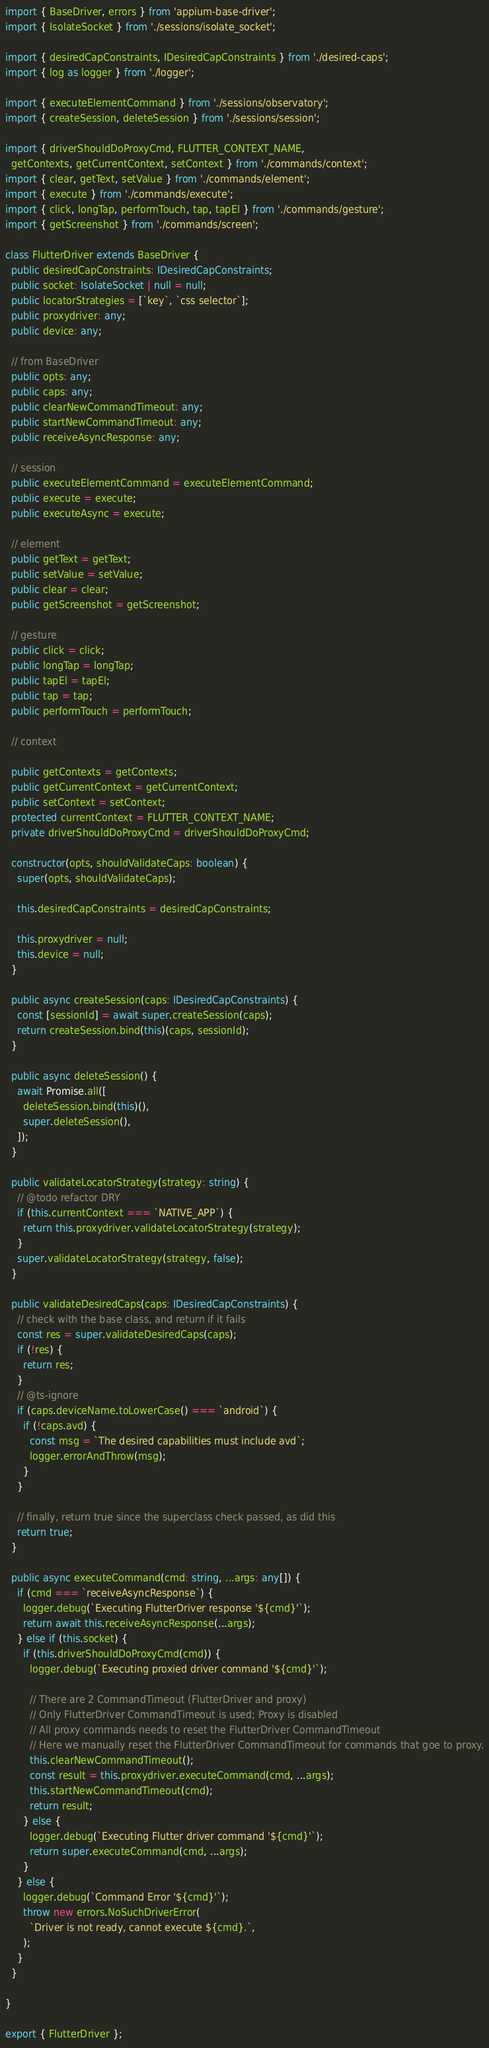<code> <loc_0><loc_0><loc_500><loc_500><_TypeScript_>import { BaseDriver, errors } from 'appium-base-driver';
import { IsolateSocket } from './sessions/isolate_socket';

import { desiredCapConstraints, IDesiredCapConstraints } from './desired-caps';
import { log as logger } from './logger';

import { executeElementCommand } from './sessions/observatory';
import { createSession, deleteSession } from './sessions/session';

import { driverShouldDoProxyCmd, FLUTTER_CONTEXT_NAME,
  getContexts, getCurrentContext, setContext } from './commands/context';
import { clear, getText, setValue } from './commands/element';
import { execute } from './commands/execute';
import { click, longTap, performTouch, tap, tapEl } from './commands/gesture';
import { getScreenshot } from './commands/screen';

class FlutterDriver extends BaseDriver {
  public desiredCapConstraints: IDesiredCapConstraints;
  public socket: IsolateSocket | null = null;
  public locatorStrategies = [`key`, `css selector`];
  public proxydriver: any;
  public device: any;

  // from BaseDriver
  public opts: any;
  public caps: any;
  public clearNewCommandTimeout: any;
  public startNewCommandTimeout: any;
  public receiveAsyncResponse: any;

  // session
  public executeElementCommand = executeElementCommand;
  public execute = execute;
  public executeAsync = execute;

  // element
  public getText = getText;
  public setValue = setValue;
  public clear = clear;
  public getScreenshot = getScreenshot;

  // gesture
  public click = click;
  public longTap = longTap;
  public tapEl = tapEl;
  public tap = tap;
  public performTouch = performTouch;

  // context

  public getContexts = getContexts;
  public getCurrentContext = getCurrentContext;
  public setContext = setContext;
  protected currentContext = FLUTTER_CONTEXT_NAME;
  private driverShouldDoProxyCmd = driverShouldDoProxyCmd;

  constructor(opts, shouldValidateCaps: boolean) {
    super(opts, shouldValidateCaps);

    this.desiredCapConstraints = desiredCapConstraints;

    this.proxydriver = null;
    this.device = null;
  }

  public async createSession(caps: IDesiredCapConstraints) {
    const [sessionId] = await super.createSession(caps);
    return createSession.bind(this)(caps, sessionId);
  }

  public async deleteSession() {
    await Promise.all([
      deleteSession.bind(this)(),
      super.deleteSession(),
    ]);
  }

  public validateLocatorStrategy(strategy: string) {
    // @todo refactor DRY
    if (this.currentContext === `NATIVE_APP`) {
      return this.proxydriver.validateLocatorStrategy(strategy);
    }
    super.validateLocatorStrategy(strategy, false);
  }

  public validateDesiredCaps(caps: IDesiredCapConstraints) {
    // check with the base class, and return if it fails
    const res = super.validateDesiredCaps(caps);
    if (!res) {
      return res;
    }
    // @ts-ignore
    if (caps.deviceName.toLowerCase() === `android`) {
      if (!caps.avd) {
        const msg = `The desired capabilities must include avd`;
        logger.errorAndThrow(msg);
      }
    }

    // finally, return true since the superclass check passed, as did this
    return true;
  }

  public async executeCommand(cmd: string, ...args: any[]) {
    if (cmd === `receiveAsyncResponse`) {
      logger.debug(`Executing FlutterDriver response '${cmd}'`);
      return await this.receiveAsyncResponse(...args);
    } else if (this.socket) {
      if (this.driverShouldDoProxyCmd(cmd)) {
        logger.debug(`Executing proxied driver command '${cmd}'`);

        // There are 2 CommandTimeout (FlutterDriver and proxy)
        // Only FlutterDriver CommandTimeout is used; Proxy is disabled
        // All proxy commands needs to reset the FlutterDriver CommandTimeout
        // Here we manually reset the FlutterDriver CommandTimeout for commands that goe to proxy.
        this.clearNewCommandTimeout();
        const result = this.proxydriver.executeCommand(cmd, ...args);
        this.startNewCommandTimeout(cmd);
        return result;
      } else {
        logger.debug(`Executing Flutter driver command '${cmd}'`);
        return super.executeCommand(cmd, ...args);
      }
    } else {
      logger.debug(`Command Error '${cmd}'`);
      throw new errors.NoSuchDriverError(
        `Driver is not ready, cannot execute ${cmd}.`,
      );
    }
  }

}

export { FlutterDriver };
</code> 